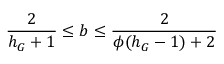<formula> <loc_0><loc_0><loc_500><loc_500>\frac { 2 } { h _ { G } + 1 } \leq b \leq \frac { 2 } { \phi ( h _ { G } - 1 ) + 2 }</formula> 